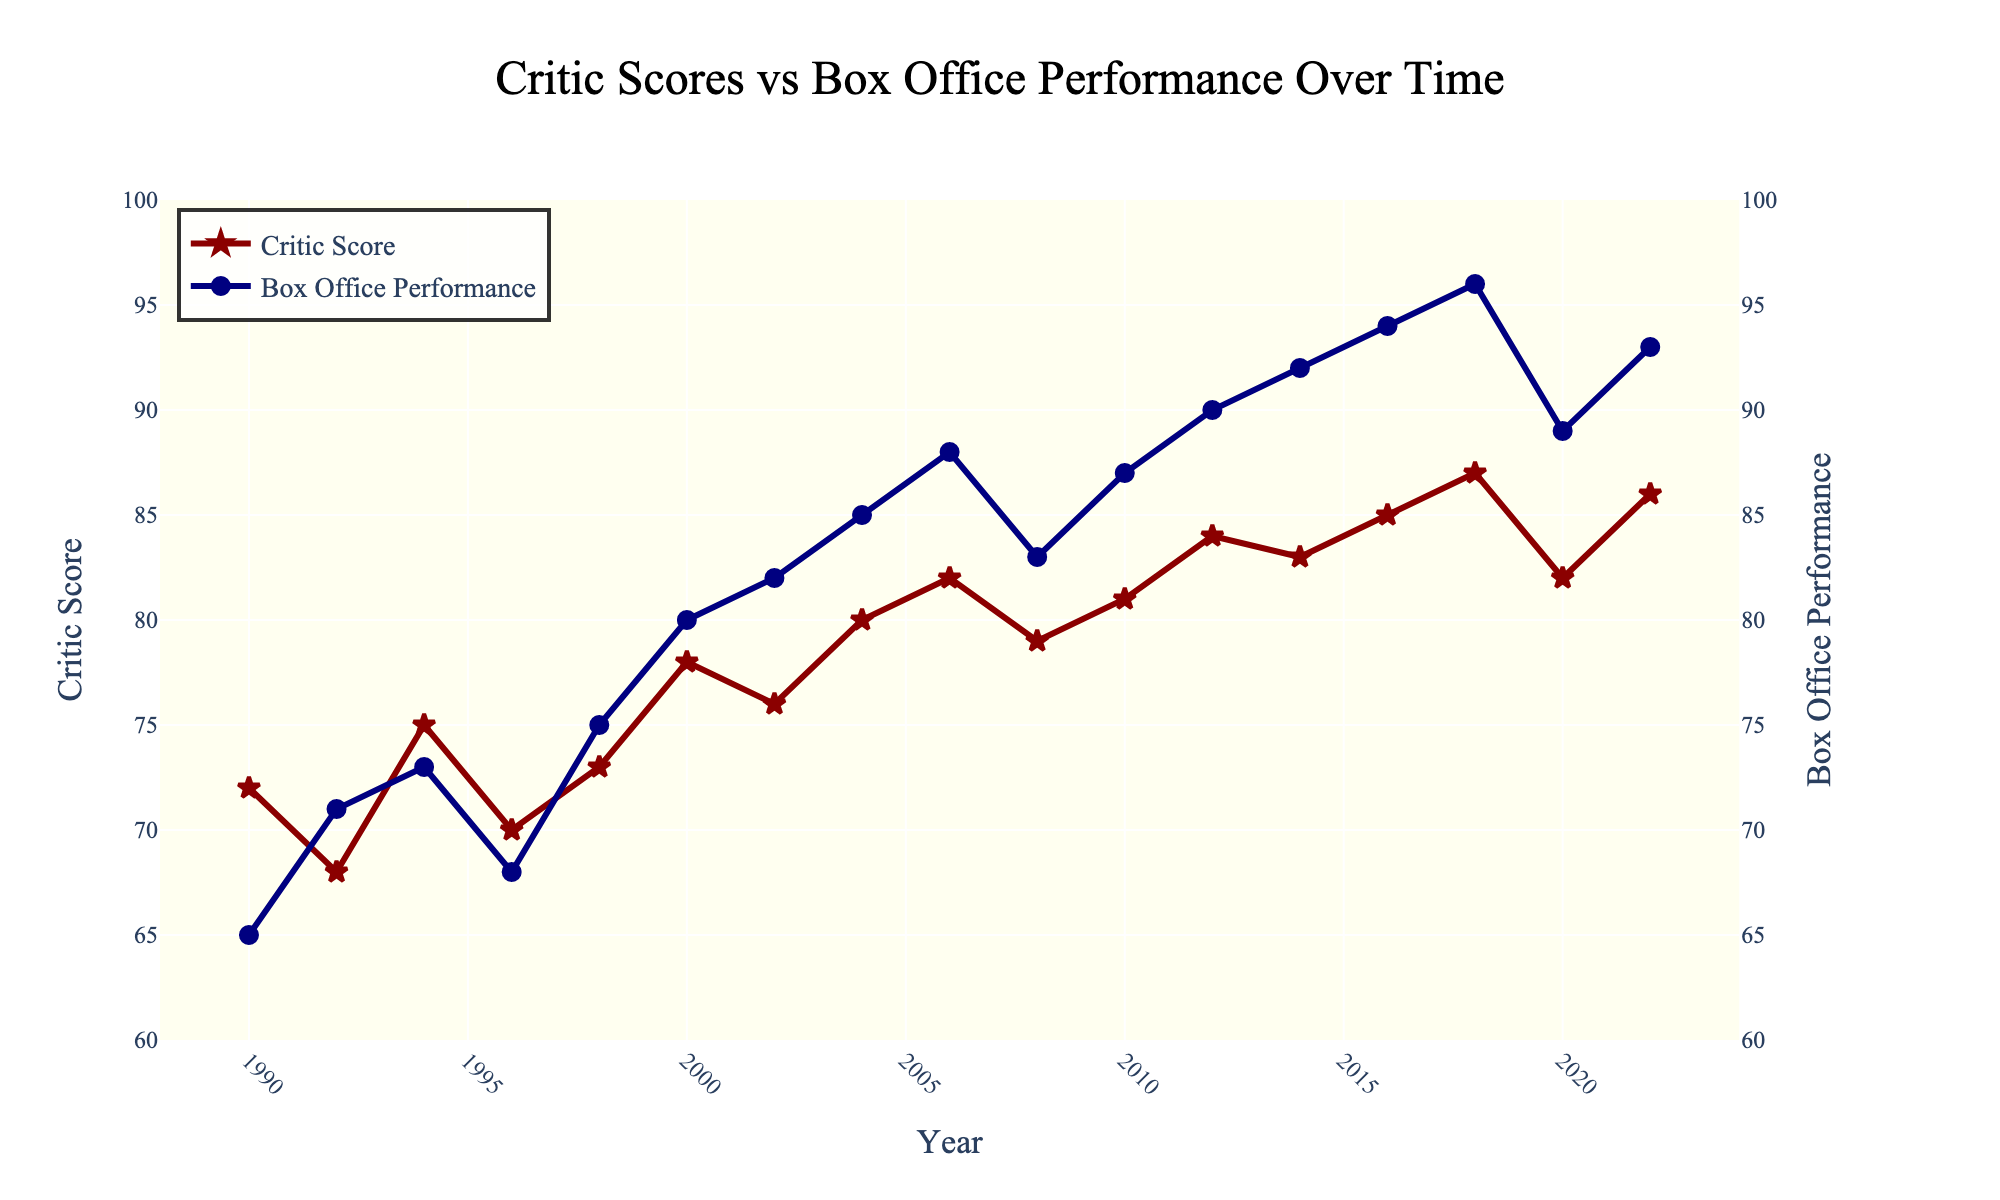what year had the highest Box Office Performance? Identify the tallest "Box Office Performance" point on the plot and check its corresponding year on the x-axis. Based on the visual, the highest Box Office Performance appears in 2018, 2020, and 2022. However, 2022 had the highest at 96.
Answer: 2022 Which year had the lowest Critic Score and what was the score? Identify the lowest "Critic Score" point on the plot and check its corresponding year on the x-axis. The lowest score is in 1992 with a Critic Score of 68.
Answer: 1992, 68 In which year was the gap between Critic Score and Box Office Performance the smallest? To determine the smallest gap, calculate the absolute difference between the Critic Score and Box Office Performance for each year by visually inspecting the plot. The smallest gap is in 2010 where Critic Score is 81 and Box Office is 87 giving a difference of only 6.
Answer: 2010 Was there any year when the Box Office Performance decreased compared to the previous year? Check for any downward trends in the "Box Office Performance" line from one year to the next. The Box Office Performance decreased between 2018 and 2020 (from 96 to 89).
Answer: Yes, between 2018 and 2020 What is the average Critic Score over the entire period? Calculate the mean of all Critic Scores from the plot. Sum the scores (72+68+75+70+73+78+76+80+82+79+81+84+83+85+87+82+86=1271) and divide by 17 (number of years). 1271/17 ≈ 74.
Answer: 74.76 Which color represents the Critic Score line? Identify the color of the line representing Critic Score on the plot. Critic Scores are represented by a dark red line.
Answer: dark red In what year did both Critic Score and Box Office Performance see significant increases and what were their values? Look for any visible jumps in both graphs, where both Critic Score and Box Office Performance increased. In 2018, Critic Score went from 85 to 87, and Box Office Performance went from 94 to 96.
Answer: 2018; Critic Score: 87, Box Office Performance: 96 How many years show a higher Critic Score compared to Box Office Performance? Count the number of points where the Critic Score line is higher than the Box Office Performance line. There are no instances where the Critic Score is higher than the Box Office Performance throughout the figure.
Answer: 0 What was the Critic Score in 2008 and how did it compare to the previous year? Identify the Critic Score in 2008 and compare it to the score in 2006. In 2008, the score is 79, which is a decrease from 82 in 2006.
Answer: 2008: 79; Decrease by 3 from 2006 